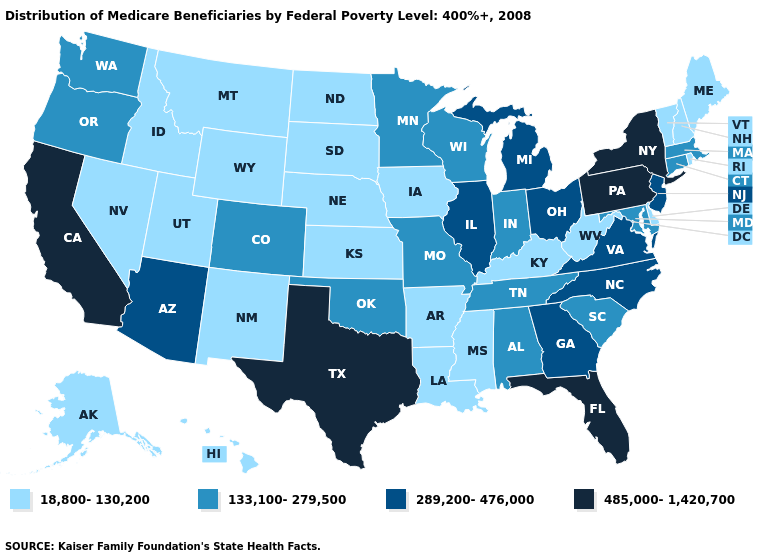Name the states that have a value in the range 18,800-130,200?
Keep it brief. Alaska, Arkansas, Delaware, Hawaii, Idaho, Iowa, Kansas, Kentucky, Louisiana, Maine, Mississippi, Montana, Nebraska, Nevada, New Hampshire, New Mexico, North Dakota, Rhode Island, South Dakota, Utah, Vermont, West Virginia, Wyoming. Does Maine have a lower value than New Hampshire?
Give a very brief answer. No. Among the states that border Minnesota , does Iowa have the highest value?
Concise answer only. No. How many symbols are there in the legend?
Give a very brief answer. 4. Is the legend a continuous bar?
Short answer required. No. What is the value of Massachusetts?
Keep it brief. 133,100-279,500. What is the lowest value in the West?
Write a very short answer. 18,800-130,200. Does Colorado have the same value as Missouri?
Keep it brief. Yes. Name the states that have a value in the range 289,200-476,000?
Quick response, please. Arizona, Georgia, Illinois, Michigan, New Jersey, North Carolina, Ohio, Virginia. Which states have the lowest value in the USA?
Concise answer only. Alaska, Arkansas, Delaware, Hawaii, Idaho, Iowa, Kansas, Kentucky, Louisiana, Maine, Mississippi, Montana, Nebraska, Nevada, New Hampshire, New Mexico, North Dakota, Rhode Island, South Dakota, Utah, Vermont, West Virginia, Wyoming. Name the states that have a value in the range 485,000-1,420,700?
Concise answer only. California, Florida, New York, Pennsylvania, Texas. What is the lowest value in states that border Nevada?
Be succinct. 18,800-130,200. Which states have the lowest value in the South?
Concise answer only. Arkansas, Delaware, Kentucky, Louisiana, Mississippi, West Virginia. Name the states that have a value in the range 289,200-476,000?
Answer briefly. Arizona, Georgia, Illinois, Michigan, New Jersey, North Carolina, Ohio, Virginia. Does the map have missing data?
Concise answer only. No. 